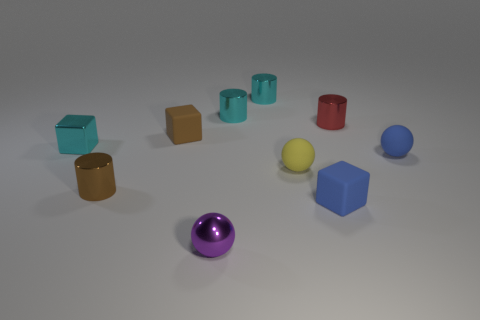Subtract all rubber spheres. How many spheres are left? 1 Add 2 small brown metal blocks. How many small brown metal blocks exist? 2 Subtract all brown blocks. How many blocks are left? 2 Subtract 0 red cubes. How many objects are left? 10 Subtract all cylinders. How many objects are left? 6 Subtract 4 cylinders. How many cylinders are left? 0 Subtract all purple cylinders. Subtract all gray spheres. How many cylinders are left? 4 Subtract all brown balls. How many brown blocks are left? 1 Subtract all small blue blocks. Subtract all cyan cylinders. How many objects are left? 7 Add 8 tiny cyan cubes. How many tiny cyan cubes are left? 9 